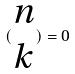Convert formula to latex. <formula><loc_0><loc_0><loc_500><loc_500>( \begin{matrix} n \\ k \end{matrix} ) = 0</formula> 